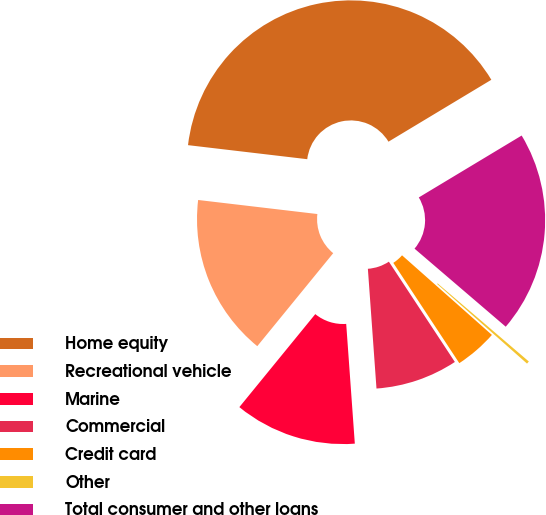<chart> <loc_0><loc_0><loc_500><loc_500><pie_chart><fcel>Home equity<fcel>Recreational vehicle<fcel>Marine<fcel>Commercial<fcel>Credit card<fcel>Other<fcel>Total consumer and other loans<nl><fcel>39.51%<fcel>15.97%<fcel>12.04%<fcel>8.12%<fcel>4.2%<fcel>0.27%<fcel>19.89%<nl></chart> 